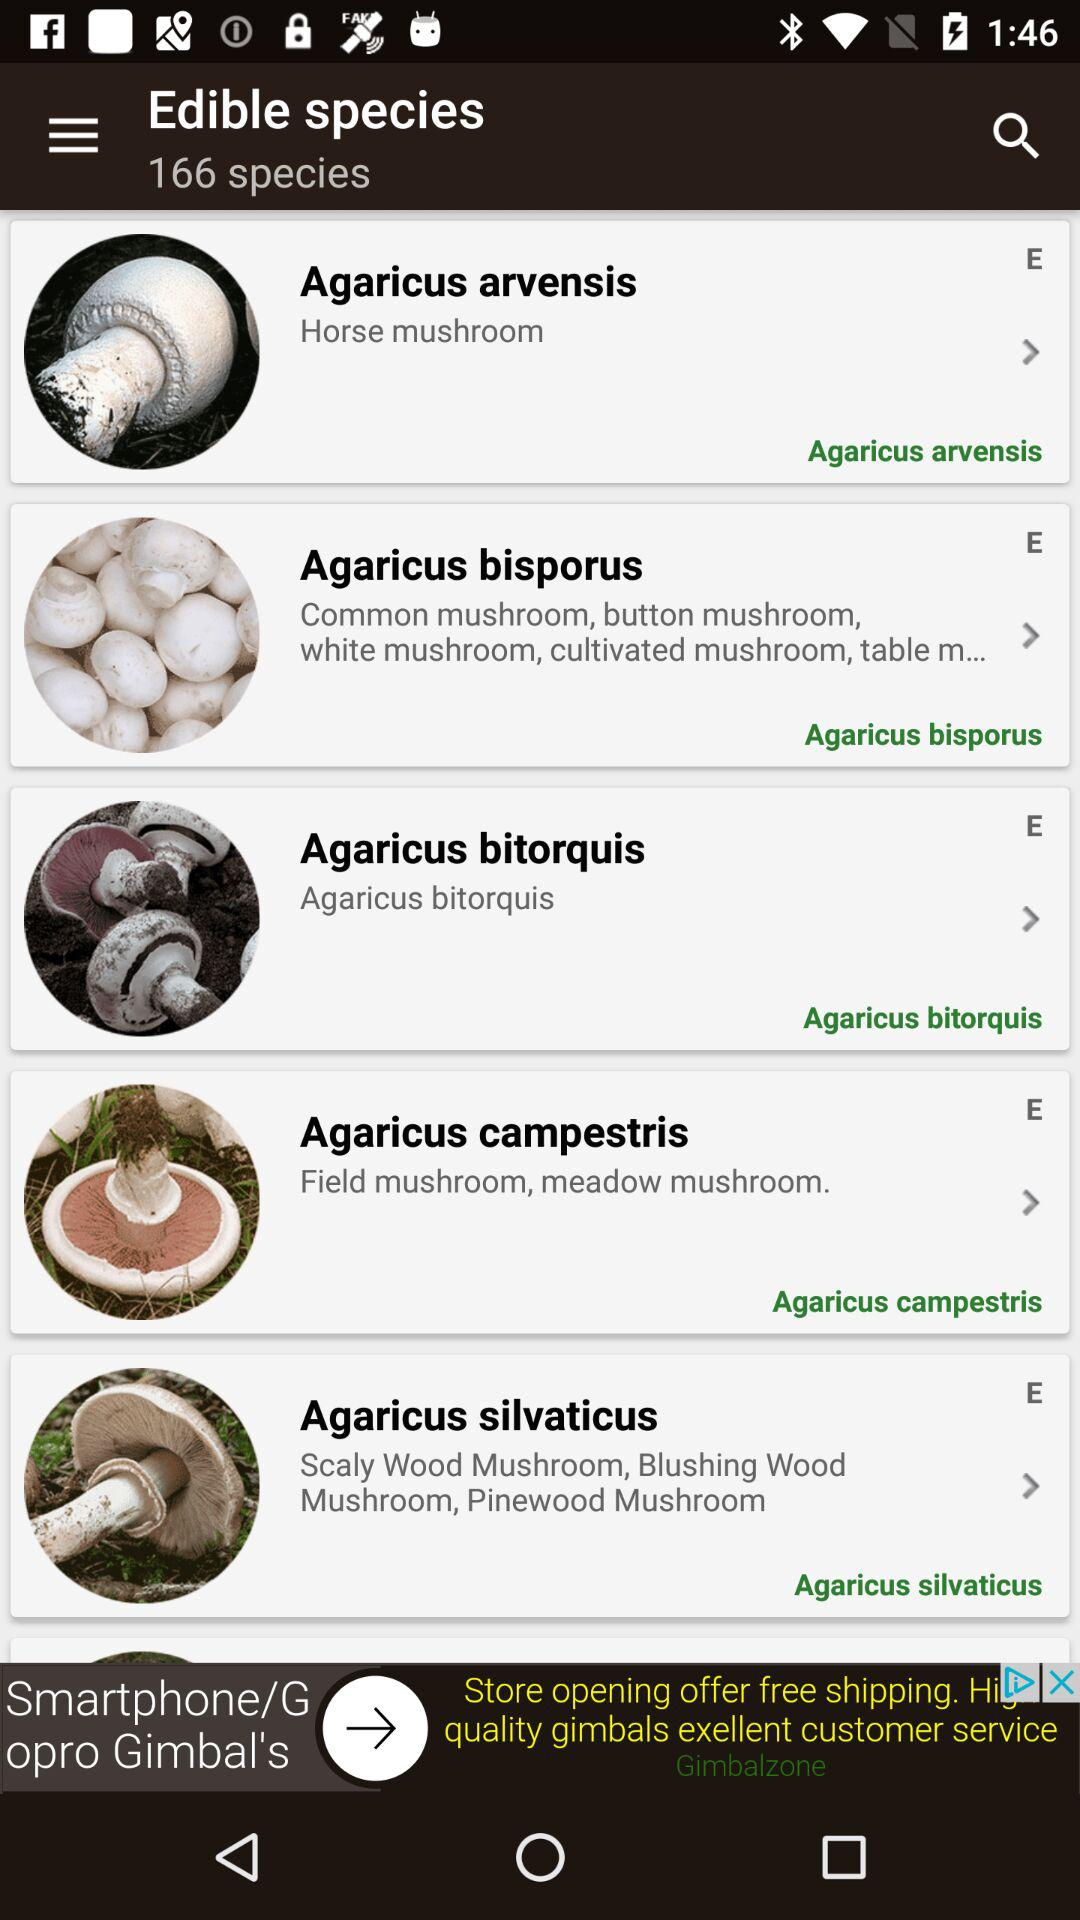How many species of mushrooms are there? There are 166 species of mushrooms. 